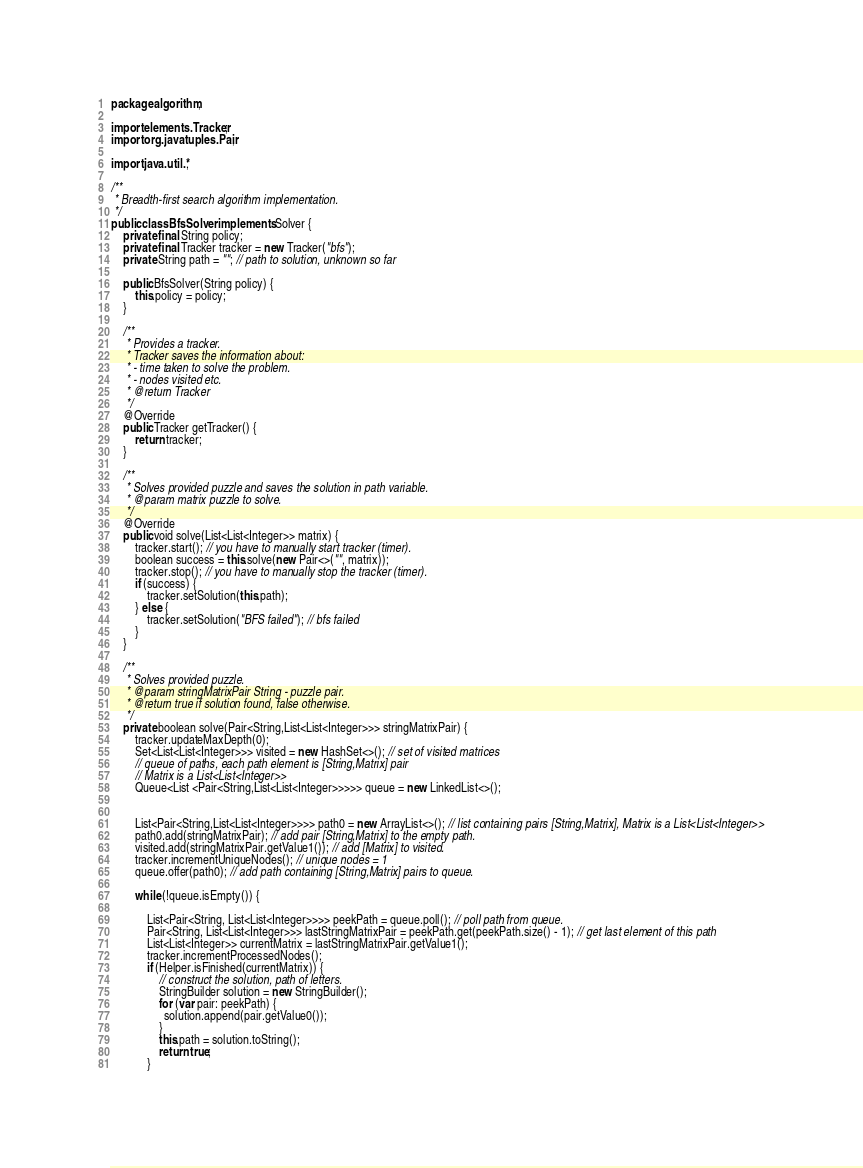<code> <loc_0><loc_0><loc_500><loc_500><_Java_>package algorithm;

import elements.Tracker;
import org.javatuples.Pair;

import java.util.*;

/**
 * Breadth-first search algorithm implementation.
 */
public class BfsSolver implements Solver {
    private final String policy;
    private final Tracker tracker = new Tracker("bfs");
    private String path = ""; // path to solution, unknown so far

    public BfsSolver(String policy) {
        this.policy = policy;
    }

    /**
     * Provides a tracker.
     * Tracker saves the information about:
     * - time taken to solve the problem.
     * - nodes visited etc.
     * @return Tracker
     */
    @Override
    public Tracker getTracker() {
        return tracker;
    }

    /**
     * Solves provided puzzle and saves the solution in path variable.
     * @param matrix puzzle to solve.
     */
    @Override
    public void solve(List<List<Integer>> matrix) {
        tracker.start(); // you have to manually start tracker (timer).
        boolean success = this.solve(new Pair<>("", matrix));
        tracker.stop(); // you have to manually stop the tracker (timer).
        if (success) {
            tracker.setSolution(this.path);
        } else {
            tracker.setSolution("BFS failed"); // bfs failed
        }
    }

    /**
     * Solves provided puzzle.
     * @param stringMatrixPair String - puzzle pair.
     * @return true if solution found, false otherwise.
     */
    private boolean solve(Pair<String,List<List<Integer>>> stringMatrixPair) {
        tracker.updateMaxDepth(0);
        Set<List<List<Integer>>> visited = new HashSet<>(); // set of visited matrices
        // queue of paths, each path element is [String,Matrix] pair
        // Matrix is a List<List<Integer>>
        Queue<List <Pair<String,List<List<Integer>>>>> queue = new LinkedList<>();


        List<Pair<String,List<List<Integer>>>> path0 = new ArrayList<>(); // list containing pairs [String,Matrix], Matrix is a List<List<Integer>>
        path0.add(stringMatrixPair); // add pair [String,Matrix] to the empty path.
        visited.add(stringMatrixPair.getValue1()); // add [Matrix] to visited.
        tracker.incrementUniqueNodes(); // unique nodes = 1
        queue.offer(path0); // add path containing [String,Matrix] pairs to queue.

        while (!queue.isEmpty()) {

            List<Pair<String, List<List<Integer>>>> peekPath = queue.poll(); // poll path from queue.
            Pair<String, List<List<Integer>>> lastStringMatrixPair = peekPath.get(peekPath.size() - 1); // get last element of this path
            List<List<Integer>> currentMatrix = lastStringMatrixPair.getValue1();
            tracker.incrementProcessedNodes();
            if (Helper.isFinished(currentMatrix)) {
                // construct the solution, path of letters.
                StringBuilder solution = new StringBuilder();
                for (var pair: peekPath) {
                  solution.append(pair.getValue0());
                }
                this.path = solution.toString();
                return true;
            }
</code> 